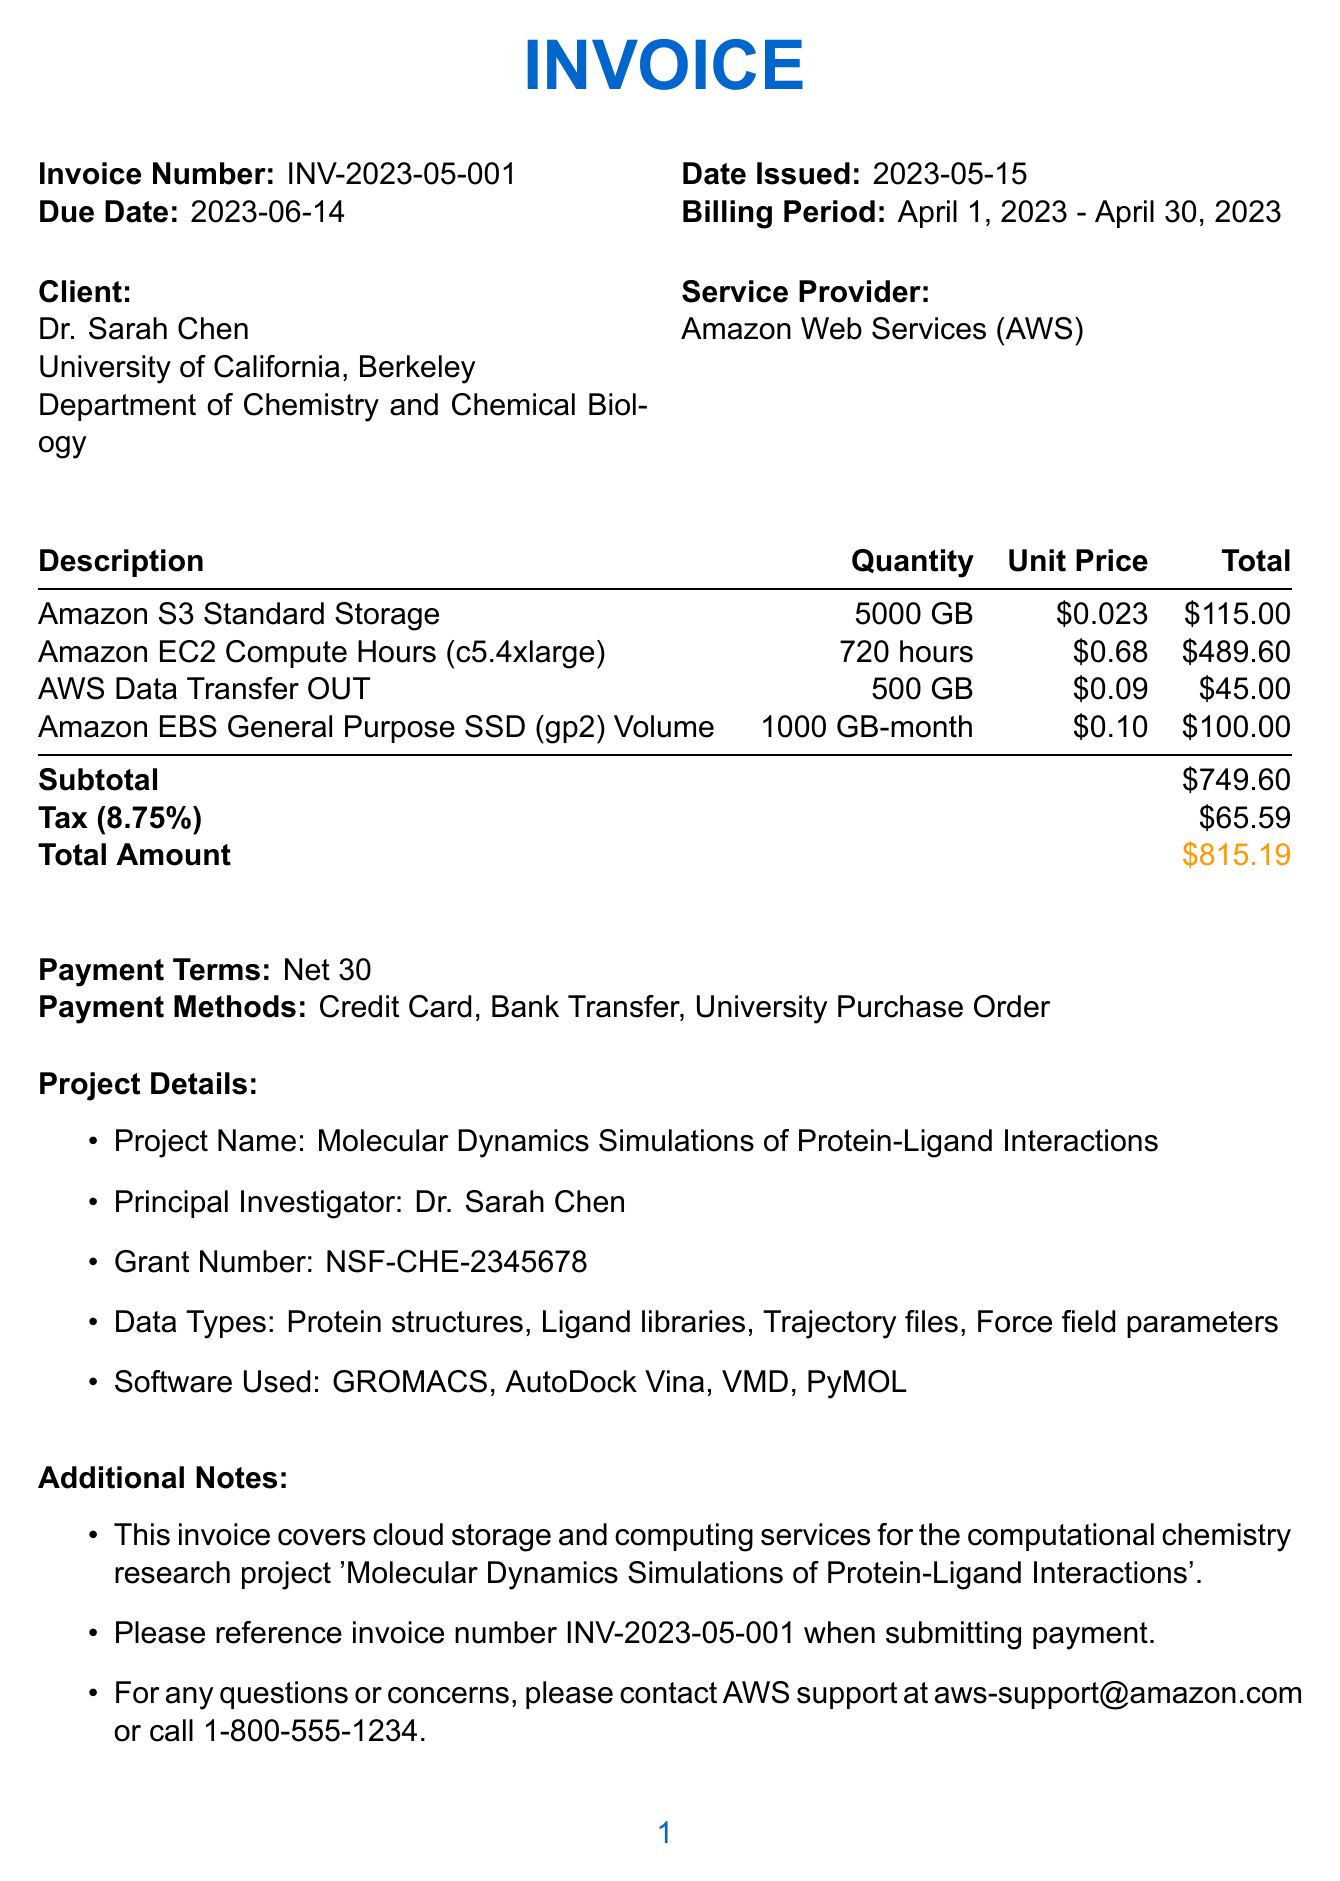What is the invoice number? The invoice number is clearly stated in the invoice header.
Answer: INV-2023-05-001 Who is the principal investigator? The principal investigator is mentioned in the project details section of the invoice.
Answer: Dr. Sarah Chen What is the total amount due? The total amount is summarized at the end of the invoice.
Answer: $815.19 What services were charged for storage? The services can be found in the itemized list on the invoice.
Answer: Amazon S3 Standard Storage What was the billing period for this invoice? The billing period is specified near the top of the invoice.
Answer: April 1, 2023 - April 30, 2023 What is the tax rate applied to the invoice? The tax rate is mentioned alongside the tax calculations in the invoice.
Answer: 8.75% Which department is the client from? The department is listed under the client information section of the invoice.
Answer: Department of Chemistry and Chemical Biology What payment methods are accepted? The payment methods are outlined in the payment terms section.
Answer: Credit Card, Bank Transfer, University Purchase Order How many GB of AWS Data Transfer OUT were billed? The quantity of AWS Data Transfer OUT is detailed in the itemized billing section.
Answer: 500 GB What project is this invoice related to? The project name is listed in the project details section of the invoice.
Answer: Molecular Dynamics Simulations of Protein-Ligand Interactions 